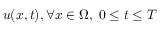<formula> <loc_0><loc_0><loc_500><loc_500>u ( x , t ) , \forall x \in \Omega , \, 0 \leq t \leq T</formula> 